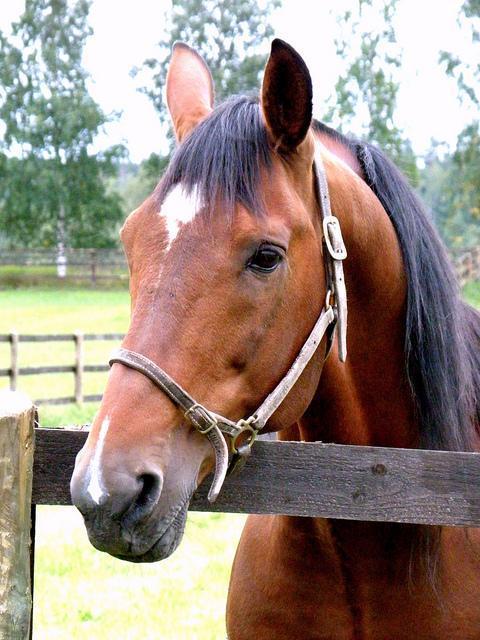How many horses are there?
Give a very brief answer. 1. How many hot dogs are there?
Give a very brief answer. 0. 